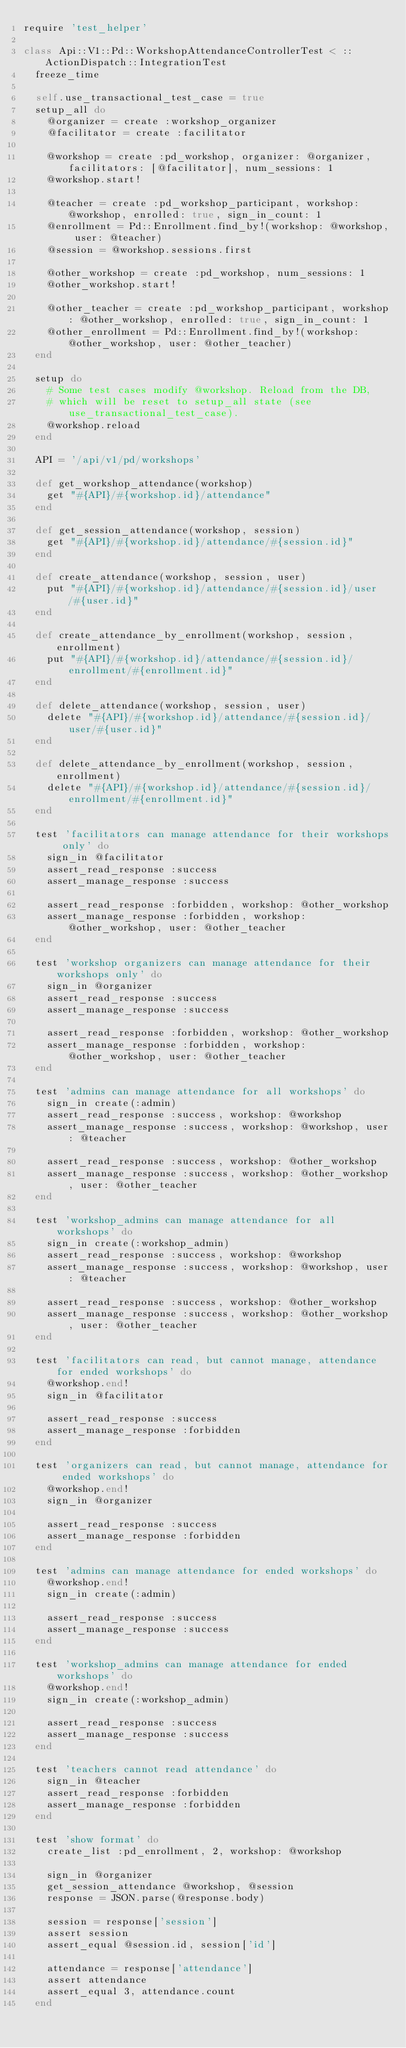<code> <loc_0><loc_0><loc_500><loc_500><_Ruby_>require 'test_helper'

class Api::V1::Pd::WorkshopAttendanceControllerTest < ::ActionDispatch::IntegrationTest
  freeze_time

  self.use_transactional_test_case = true
  setup_all do
    @organizer = create :workshop_organizer
    @facilitator = create :facilitator

    @workshop = create :pd_workshop, organizer: @organizer, facilitators: [@facilitator], num_sessions: 1
    @workshop.start!

    @teacher = create :pd_workshop_participant, workshop: @workshop, enrolled: true, sign_in_count: 1
    @enrollment = Pd::Enrollment.find_by!(workshop: @workshop, user: @teacher)
    @session = @workshop.sessions.first

    @other_workshop = create :pd_workshop, num_sessions: 1
    @other_workshop.start!

    @other_teacher = create :pd_workshop_participant, workshop: @other_workshop, enrolled: true, sign_in_count: 1
    @other_enrollment = Pd::Enrollment.find_by!(workshop: @other_workshop, user: @other_teacher)
  end

  setup do
    # Some test cases modify @workshop. Reload from the DB,
    # which will be reset to setup_all state (see use_transactional_test_case).
    @workshop.reload
  end

  API = '/api/v1/pd/workshops'

  def get_workshop_attendance(workshop)
    get "#{API}/#{workshop.id}/attendance"
  end

  def get_session_attendance(workshop, session)
    get "#{API}/#{workshop.id}/attendance/#{session.id}"
  end

  def create_attendance(workshop, session, user)
    put "#{API}/#{workshop.id}/attendance/#{session.id}/user/#{user.id}"
  end

  def create_attendance_by_enrollment(workshop, session, enrollment)
    put "#{API}/#{workshop.id}/attendance/#{session.id}/enrollment/#{enrollment.id}"
  end

  def delete_attendance(workshop, session, user)
    delete "#{API}/#{workshop.id}/attendance/#{session.id}/user/#{user.id}"
  end

  def delete_attendance_by_enrollment(workshop, session, enrollment)
    delete "#{API}/#{workshop.id}/attendance/#{session.id}/enrollment/#{enrollment.id}"
  end

  test 'facilitators can manage attendance for their workshops only' do
    sign_in @facilitator
    assert_read_response :success
    assert_manage_response :success

    assert_read_response :forbidden, workshop: @other_workshop
    assert_manage_response :forbidden, workshop: @other_workshop, user: @other_teacher
  end

  test 'workshop organizers can manage attendance for their workshops only' do
    sign_in @organizer
    assert_read_response :success
    assert_manage_response :success

    assert_read_response :forbidden, workshop: @other_workshop
    assert_manage_response :forbidden, workshop: @other_workshop, user: @other_teacher
  end

  test 'admins can manage attendance for all workshops' do
    sign_in create(:admin)
    assert_read_response :success, workshop: @workshop
    assert_manage_response :success, workshop: @workshop, user: @teacher

    assert_read_response :success, workshop: @other_workshop
    assert_manage_response :success, workshop: @other_workshop, user: @other_teacher
  end

  test 'workshop_admins can manage attendance for all workshops' do
    sign_in create(:workshop_admin)
    assert_read_response :success, workshop: @workshop
    assert_manage_response :success, workshop: @workshop, user: @teacher

    assert_read_response :success, workshop: @other_workshop
    assert_manage_response :success, workshop: @other_workshop, user: @other_teacher
  end

  test 'facilitators can read, but cannot manage, attendance for ended workshops' do
    @workshop.end!
    sign_in @facilitator

    assert_read_response :success
    assert_manage_response :forbidden
  end

  test 'organizers can read, but cannot manage, attendance for ended workshops' do
    @workshop.end!
    sign_in @organizer

    assert_read_response :success
    assert_manage_response :forbidden
  end

  test 'admins can manage attendance for ended workshops' do
    @workshop.end!
    sign_in create(:admin)

    assert_read_response :success
    assert_manage_response :success
  end

  test 'workshop_admins can manage attendance for ended workshops' do
    @workshop.end!
    sign_in create(:workshop_admin)

    assert_read_response :success
    assert_manage_response :success
  end

  test 'teachers cannot read attendance' do
    sign_in @teacher
    assert_read_response :forbidden
    assert_manage_response :forbidden
  end

  test 'show format' do
    create_list :pd_enrollment, 2, workshop: @workshop

    sign_in @organizer
    get_session_attendance @workshop, @session
    response = JSON.parse(@response.body)

    session = response['session']
    assert session
    assert_equal @session.id, session['id']

    attendance = response['attendance']
    assert attendance
    assert_equal 3, attendance.count
  end
</code> 